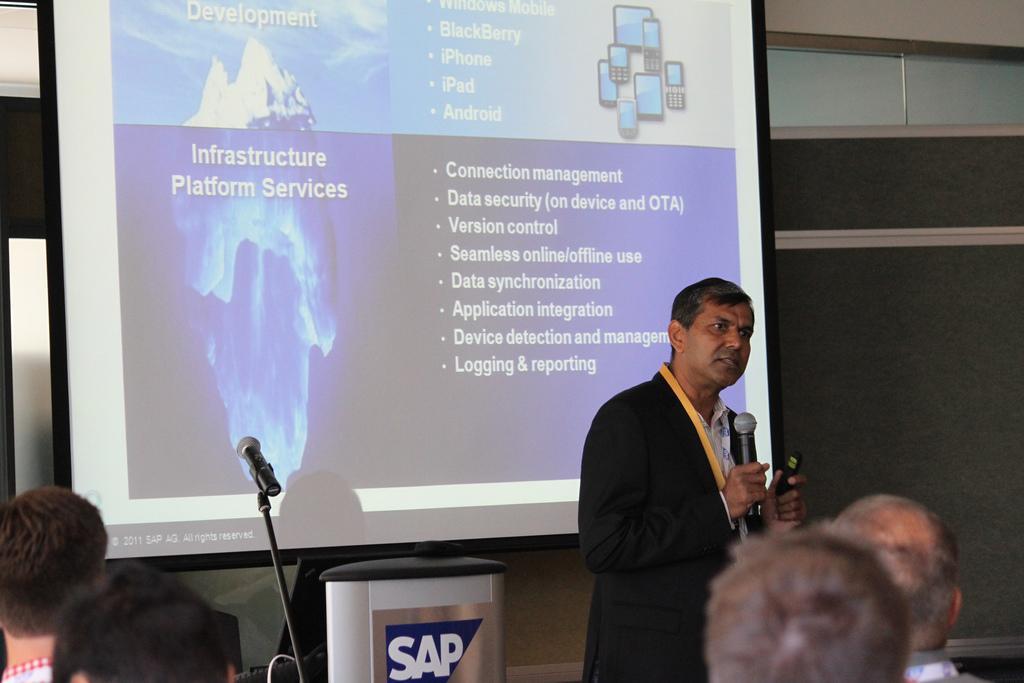How would you summarize this image in a sentence or two? In this picture I can see few people, a man standing and holding a microphone in one hand and something in another hand. I can see a projector screen in the back displaying some text and I can see another microphone to the stand. it looks like a podium at the bottom of the picture. 